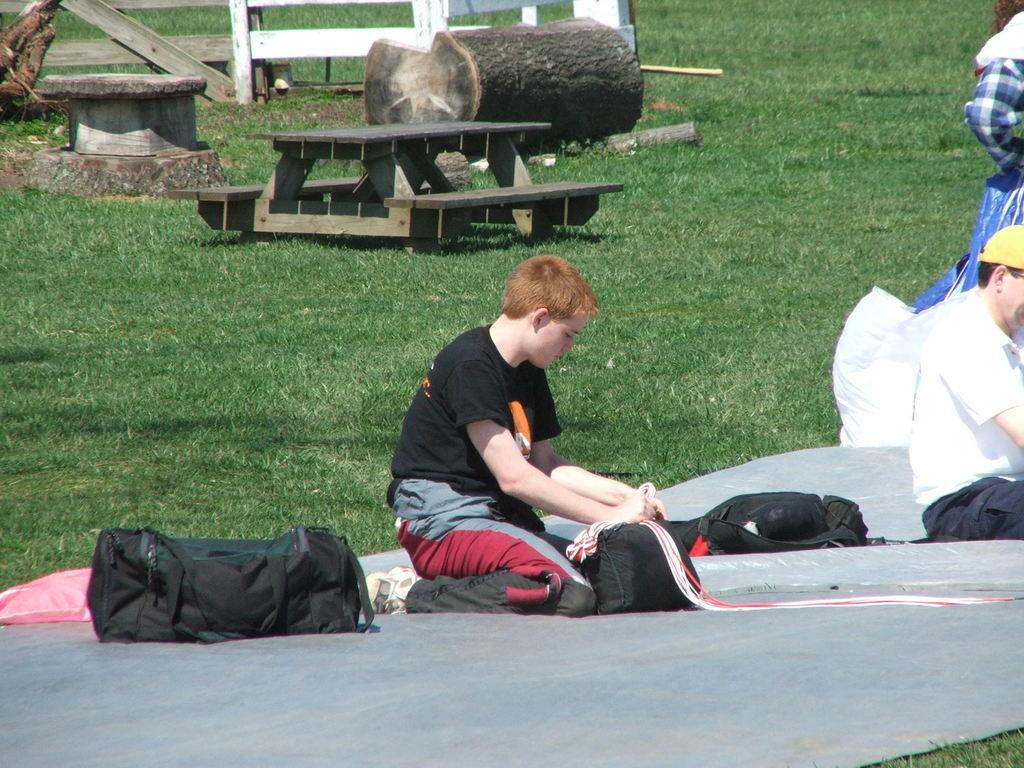Can you describe this image briefly? In this picture there is a man who is wearing yellow cap, white t-shirt and black trouser. He is sitting on the black carpet. Beside him i can see the black bag. In the center there is a boy who is wearing t-shirt, trouser and shoe. He is sitting near to the black bags. In the back I can see the table and benches. beside that I can see the wood and wooden fencing. On the right there is a woman who is standing on the grass. 